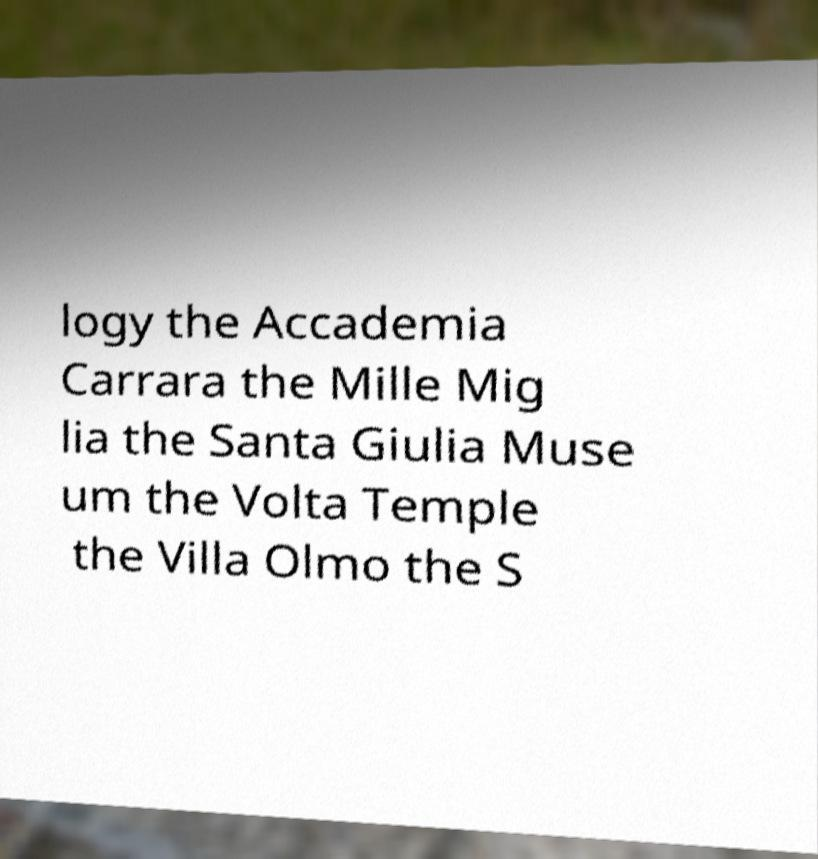Please identify and transcribe the text found in this image. logy the Accademia Carrara the Mille Mig lia the Santa Giulia Muse um the Volta Temple the Villa Olmo the S 